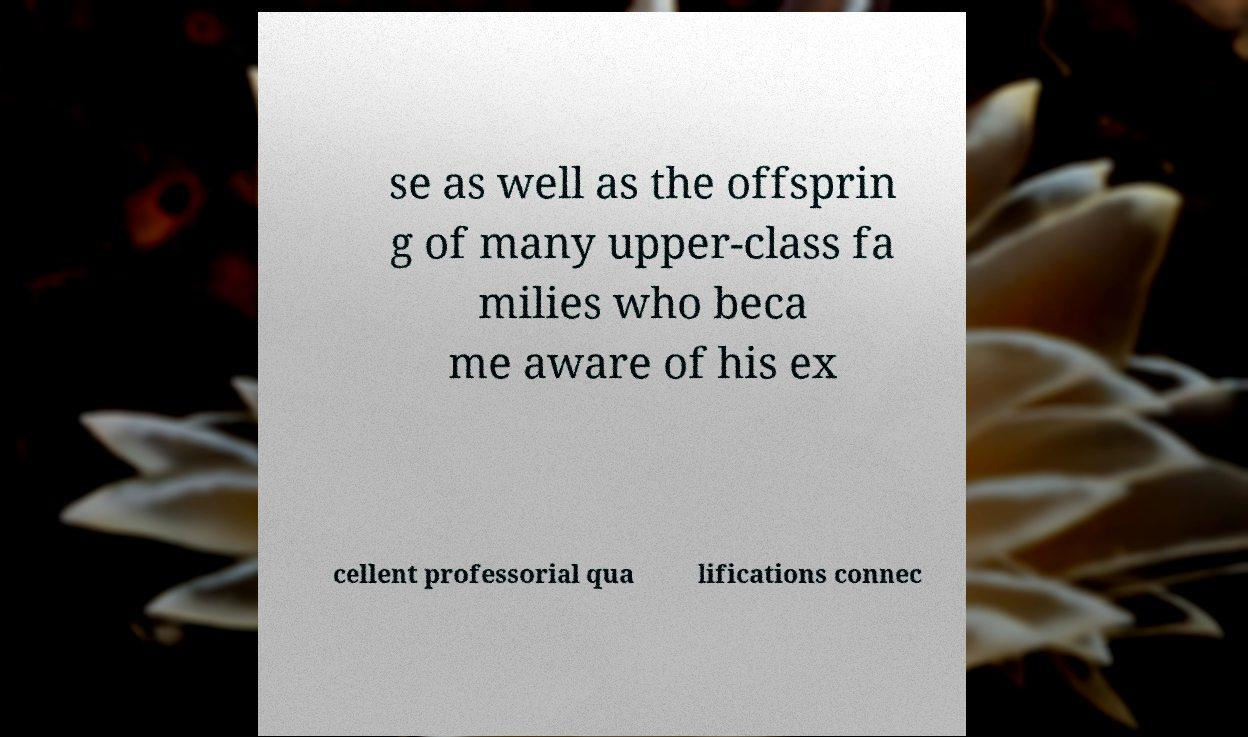Can you read and provide the text displayed in the image?This photo seems to have some interesting text. Can you extract and type it out for me? se as well as the offsprin g of many upper-class fa milies who beca me aware of his ex cellent professorial qua lifications connec 